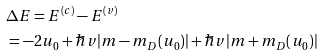Convert formula to latex. <formula><loc_0><loc_0><loc_500><loc_500>& \Delta E = E ^ { ( c ) } - E ^ { ( v ) } \\ & = - 2 u _ { 0 } + \hbar { v } | m - m _ { D } ( u _ { 0 } ) | + \hbar { v } | m + m _ { D } ( u _ { 0 } ) |</formula> 